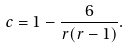<formula> <loc_0><loc_0><loc_500><loc_500>c = 1 - \frac { 6 } { r ( r - 1 ) } .</formula> 